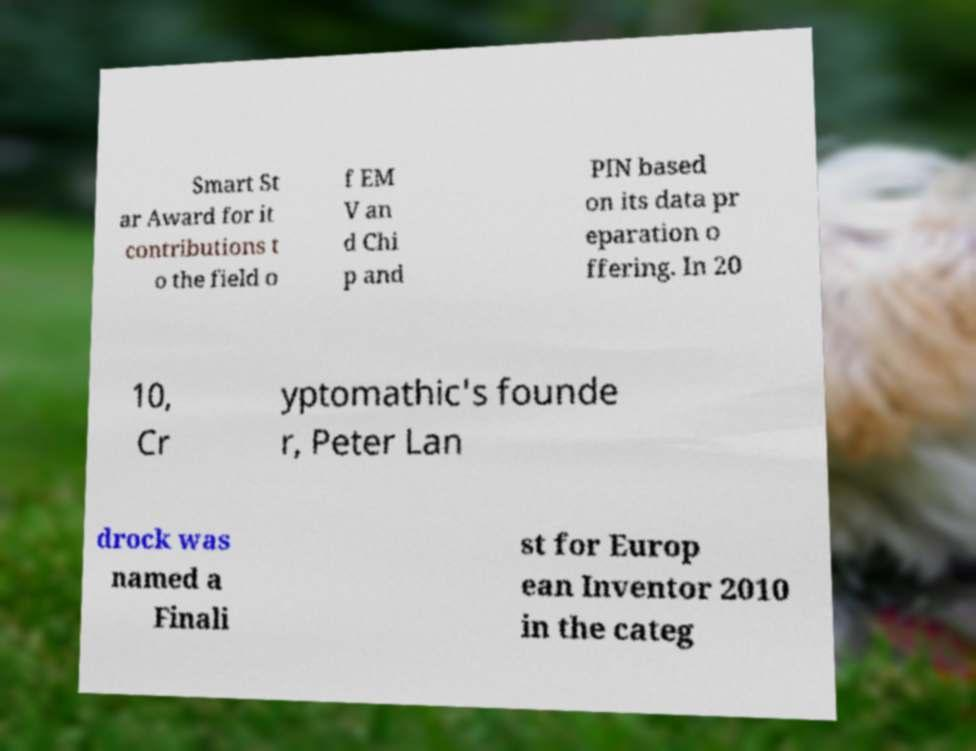Could you extract and type out the text from this image? Smart St ar Award for it contributions t o the field o f EM V an d Chi p and PIN based on its data pr eparation o ffering. In 20 10, Cr yptomathic's founde r, Peter Lan drock was named a Finali st for Europ ean Inventor 2010 in the categ 